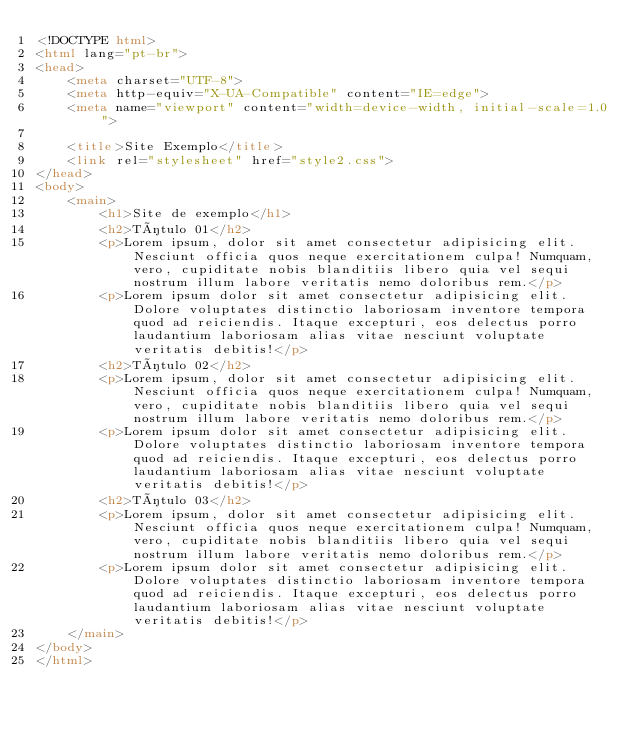<code> <loc_0><loc_0><loc_500><loc_500><_HTML_><!DOCTYPE html>
<html lang="pt-br">
<head>
    <meta charset="UTF-8">
    <meta http-equiv="X-UA-Compatible" content="IE=edge">
    <meta name="viewport" content="width=device-width, initial-scale=1.0">
   
    <title>Site Exemplo</title>
    <link rel="stylesheet" href="style2.css">
</head>
<body>
    <main>
        <h1>Site de exemplo</h1>
        <h2>Título 01</h2>
        <p>Lorem ipsum, dolor sit amet consectetur adipisicing elit. Nesciunt officia quos neque exercitationem culpa! Numquam, vero, cupiditate nobis blanditiis libero quia vel sequi nostrum illum labore veritatis nemo doloribus rem.</p>
        <p>Lorem ipsum dolor sit amet consectetur adipisicing elit. Dolore voluptates distinctio laboriosam inventore tempora quod ad reiciendis. Itaque excepturi, eos delectus porro laudantium laboriosam alias vitae nesciunt voluptate veritatis debitis!</p>
        <h2>Título 02</h2>
        <p>Lorem ipsum, dolor sit amet consectetur adipisicing elit. Nesciunt officia quos neque exercitationem culpa! Numquam, vero, cupiditate nobis blanditiis libero quia vel sequi nostrum illum labore veritatis nemo doloribus rem.</p>
        <p>Lorem ipsum dolor sit amet consectetur adipisicing elit. Dolore voluptates distinctio laboriosam inventore tempora quod ad reiciendis. Itaque excepturi, eos delectus porro laudantium laboriosam alias vitae nesciunt voluptate veritatis debitis!</p>
        <h2>Título 03</h2>
        <p>Lorem ipsum, dolor sit amet consectetur adipisicing elit. Nesciunt officia quos neque exercitationem culpa! Numquam, vero, cupiditate nobis blanditiis libero quia vel sequi nostrum illum labore veritatis nemo doloribus rem.</p>
        <p>Lorem ipsum dolor sit amet consectetur adipisicing elit. Dolore voluptates distinctio laboriosam inventore tempora quod ad reiciendis. Itaque excepturi, eos delectus porro laudantium laboriosam alias vitae nesciunt voluptate veritatis debitis!</p>
    </main>
</body>
</html></code> 